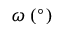<formula> <loc_0><loc_0><loc_500><loc_500>\omega \, ( ^ { \circ } )</formula> 